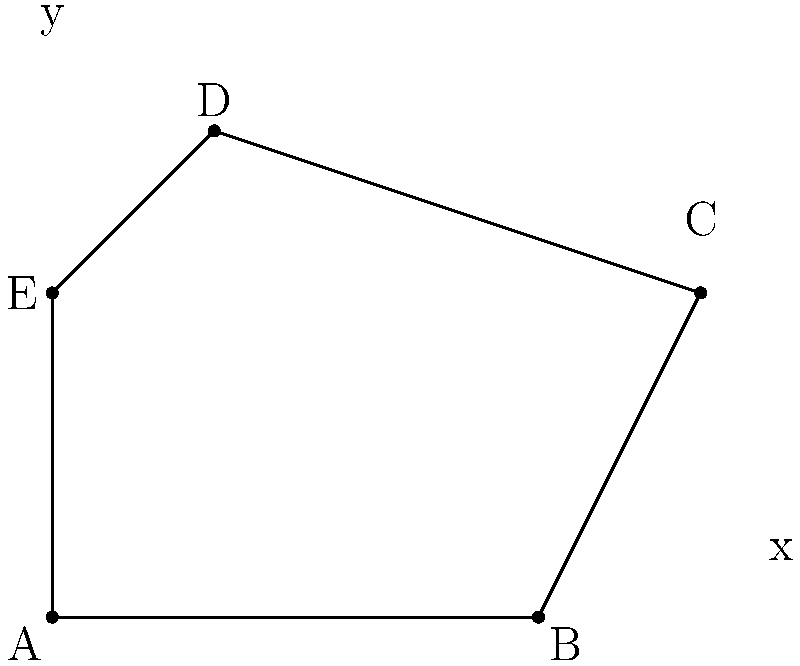In a new esports game, you're designing an irregularly shaped arena. The arena's boundary is represented by the points A(0,0), B(6,0), C(8,4), D(2,6), and E(0,4) on a coordinate plane. Calculate the area of this arena using coordinate geometry methods. To find the area of this irregular polygon, we can use the Shoelace formula (also known as the surveyor's formula). The steps are as follows:

1) First, list the coordinates in order (clockwise or counterclockwise):
   A(0,0), B(6,0), C(8,4), D(2,6), E(0,4), A(0,0)

2) Apply the Shoelace formula:
   Area = $\frac{1}{2}|((x_1y_2 + x_2y_3 + ... + x_ny_1) - (y_1x_2 + y_2x_3 + ... + y_nx_1))|$

3) Substitute the values:
   Area = $\frac{1}{2}|((0 \cdot 0 + 6 \cdot 4 + 8 \cdot 6 + 2 \cdot 4 + 0 \cdot 0) - (0 \cdot 6 + 0 \cdot 8 + 4 \cdot 2 + 6 \cdot 0 + 4 \cdot 0))|$

4) Calculate:
   Area = $\frac{1}{2}|((0 + 24 + 48 + 8 + 0) - (0 + 0 + 8 + 0 + 0))|$
   Area = $\frac{1}{2}|(80 - 8)|$
   Area = $\frac{1}{2}(72)$
   Area = 36

Therefore, the area of the irregularly shaped game arena is 36 square units.
Answer: 36 square units 